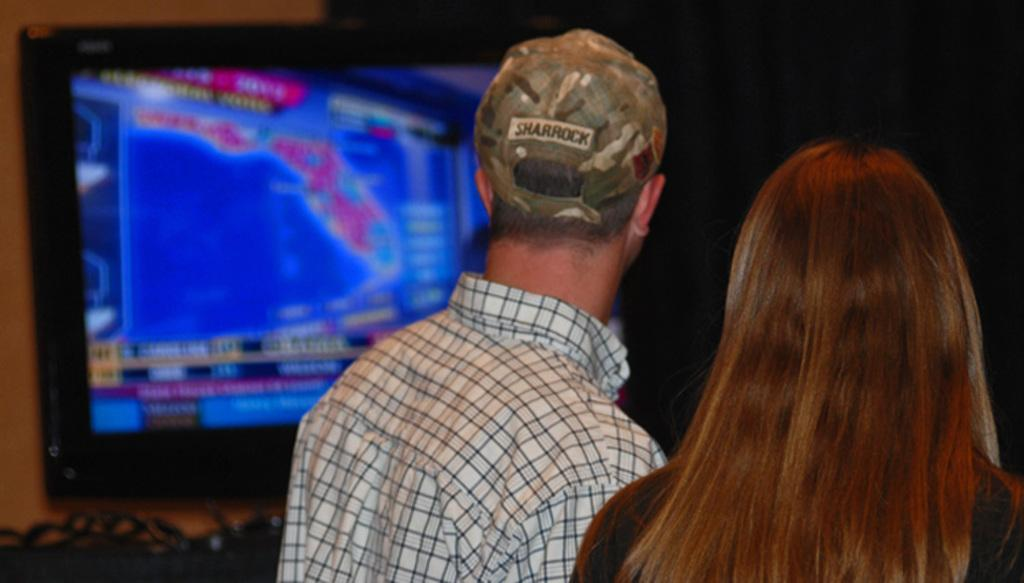What is the main subject of the image? There is a man in the image. Can you describe the man's appearance? The man is wearing a cap. Who is the man standing near in the image? The man is standing near a woman. What can be seen in the background of the image? There is a screen in the background of the image, and it is near a wall. How would you describe the overall color scheme of the background? The background of the image is dark in color. Can you hear the voice of the fog in the image? There is no fog or voice present in the image. How does the wind affect the man's cap in the image? There is no wind present in the image, and therefore it does not affect the man's cap. 